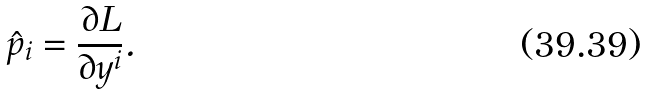<formula> <loc_0><loc_0><loc_500><loc_500>\hat { p } _ { i } = \frac { \partial L } { \partial y ^ { i } } .</formula> 